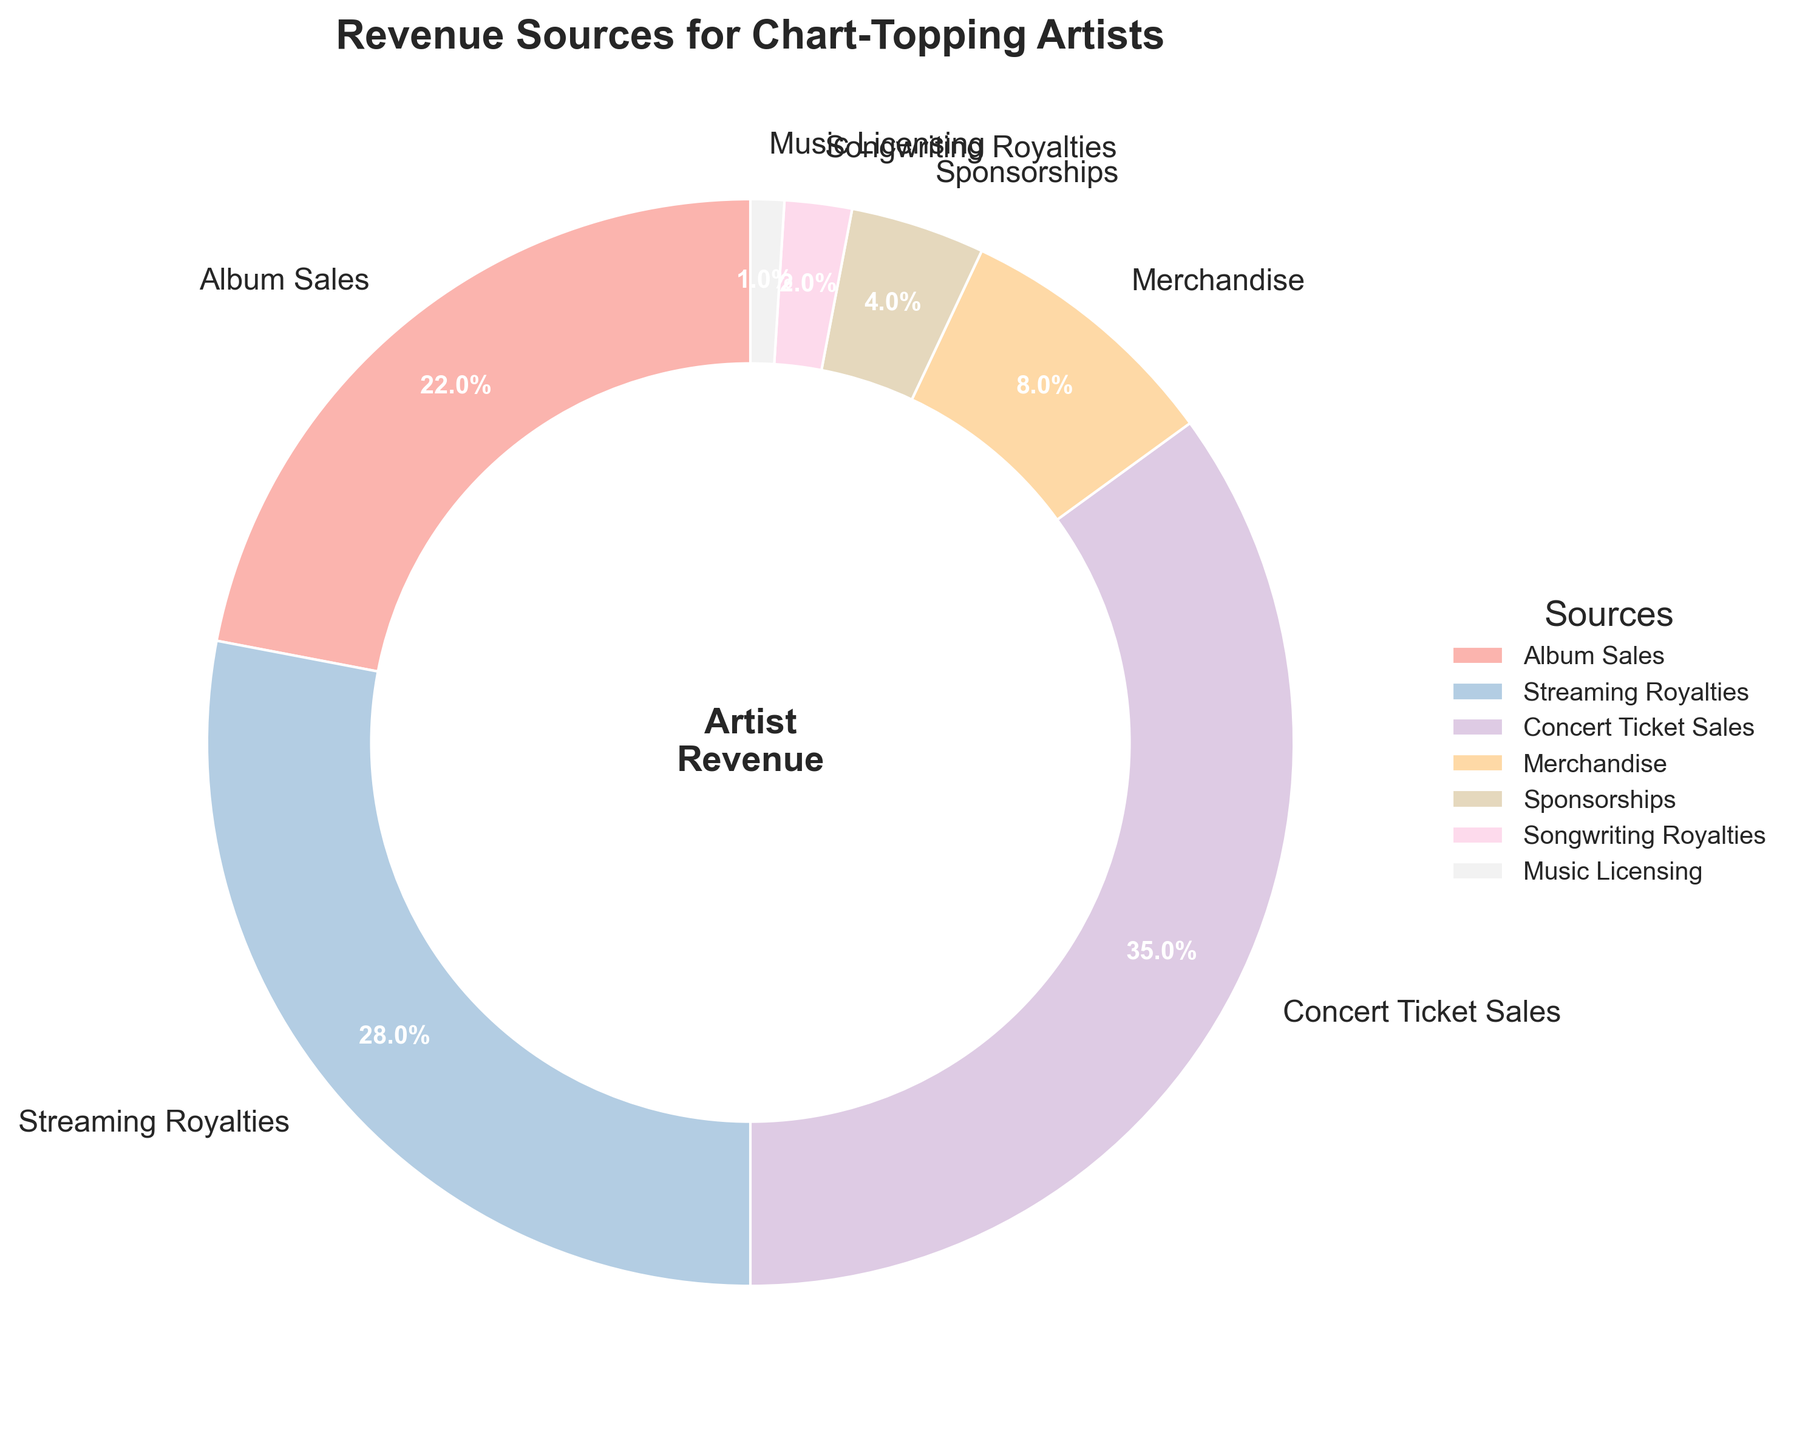What is the most significant source of revenue for chart-topping artists? The largest portion of the pie chart represents the category with the highest percentage. Here, Concert Ticket Sales occupies 35% of the pie chart, making it the largest section.
Answer: Concert Ticket Sales Which two sources contribute to more than 50% of the total revenue? By identifying the two largest slices of the pie chart, we see that Concert Ticket Sales (35%) and Streaming Royalties (28%) contribute significantly. Adding these percentages, 35% + 28% = 63%, which is more than 50%.
Answer: Concert Ticket Sales and Streaming Royalties How much more percentage does Concert Ticket Sales contribute compared to Album Sales? Subtract the percentage of Album Sales (22%) from the percentage of Concert Ticket Sales (35%): 35% - 22% = 13%.
Answer: 13% What percentage of revenue comes from sources other than Concert Ticket Sales and Streaming Royalties? Add the percentages of all sources except Concert Ticket Sales (35%) and Streaming Royalties (28%): 22% (Album Sales) + 8% (Merchandise) + 4% (Sponsorships) + 2% (Songwriting Royalties) + 1% (Music Licensing) = 37%.
Answer: 37% Which source contributes the least to the revenue? The smallest slice of the pie chart represents the source with the lowest percentage. Here, Music Licensing occupies 1% of the pie chart, making it the smallest section.
Answer: Music Licensing How do the combined percentages of Merchandise and Sponsorships compare to Album Sales? Sum the percentages of Merchandise (8%) and Sponsorships (4%): 8% + 4% = 12%. Compare this to Album Sales (22%). 12% is less than 22%.
Answer: Less than Album Sales Which sources contribute less than 5% each to the total revenue? Examining the pie chart and listing slices with percentages under 5%, we find Sponsorships (4%), Songwriting Royalties (2%), and Music Licensing (1%).
Answer: Sponsorships, Songwriting Royalties, and Music Licensing By how much does Streaming Royalties exceed the combined revenue from Songwriting Royalties and Music Licensing? Add the percentages of Songwriting Royalties (2%) and Music Licensing (1%): 2% + 1% = 3%. Compare this to Streaming Royalties (28%). Subtracting these two, 28% - 3% = 25%.
Answer: 25% What is the visual indication showing the title or main idea of the chart? The largest text at the top of the pie chart is the title which reads "Revenue Sources for Chart-Topping Artists."
Answer: Revenue Sources for Chart-Topping Artists 